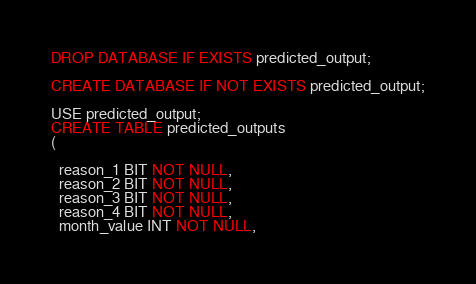Convert code to text. <code><loc_0><loc_0><loc_500><loc_500><_SQL_>DROP DATABASE IF EXISTS predicted_output;

CREATE DATABASE IF NOT EXISTS predicted_output;

USE predicted_output;
CREATE TABLE predicted_outputs
(

  reason_1 BIT NOT NULL,
  reason_2 BIT NOT NULL,
  reason_3 BIT NOT NULL,
  reason_4 BIT NOT NULL,
  month_value INT NOT NULL,</code> 